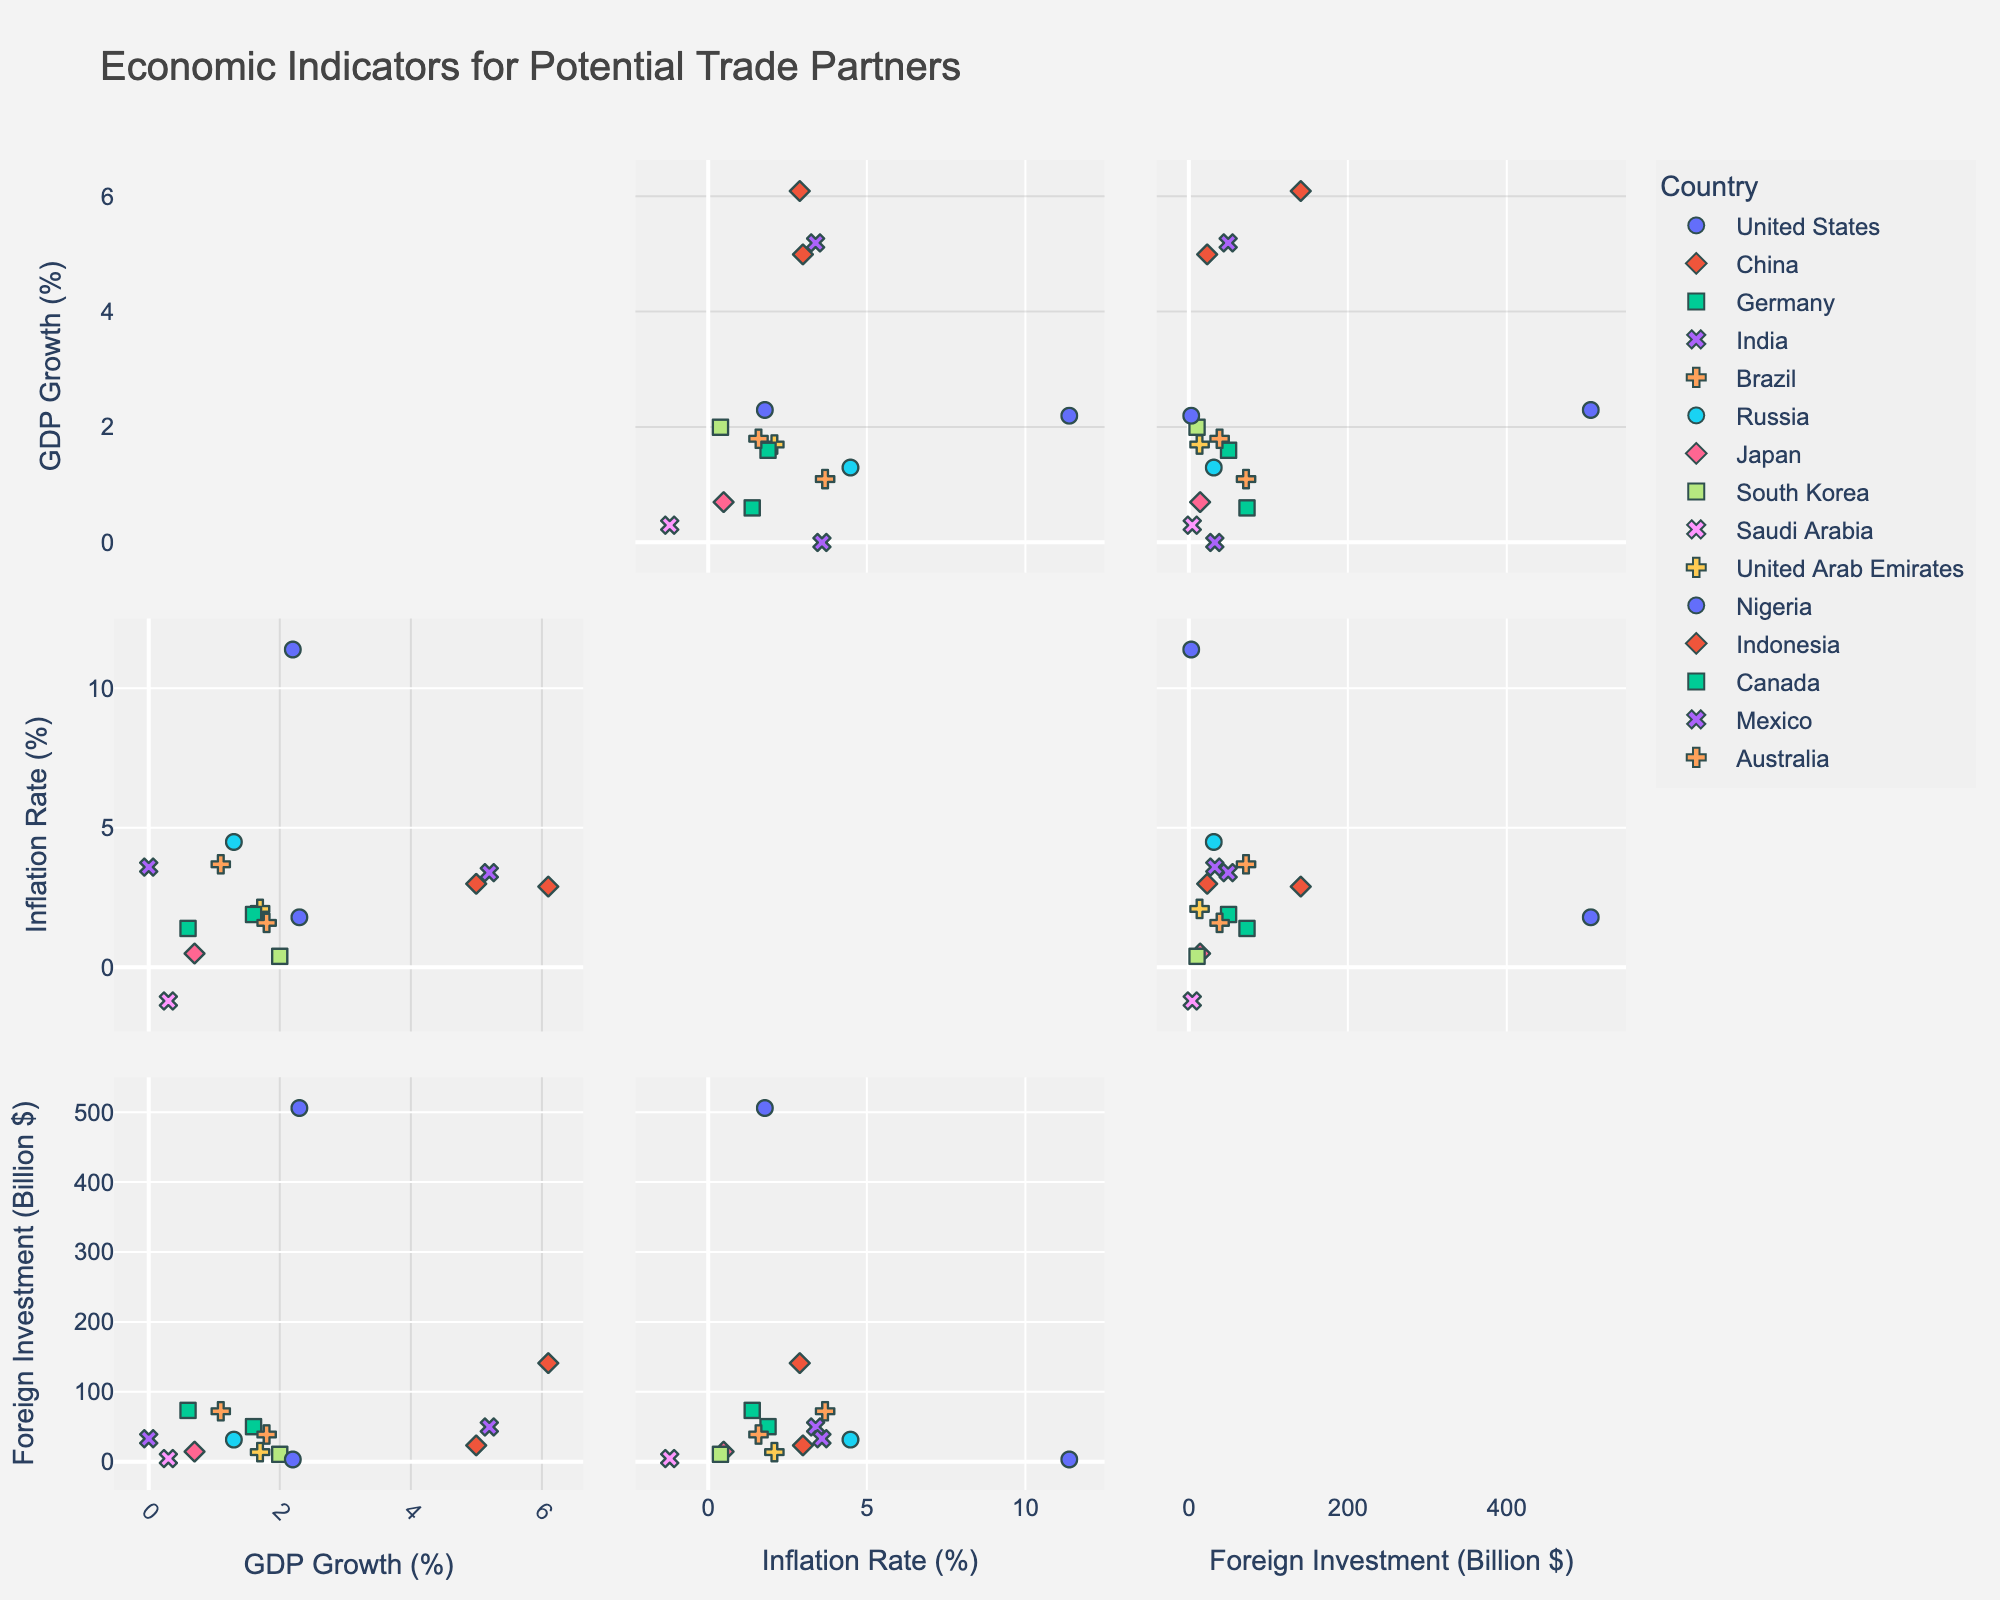What is the title of the figure? The title of the figure is displayed at the top and describes the content of the scatterplot matrix.
Answer: Economic Indicators for Potential Trade Partners How many data points represent countries with a negative inflation rate? Check the scatterplot where the Inflation Rate is plotted. Only Saudi Arabia has a negative inflation rate.
Answer: 1 Which country has the highest foreign investment? Locate the data point with the highest value on the Foreign Investment axis. The United States shows the highest foreign investment.
Answer: United States What is the GDP growth rate of Germany? Find the data point for Germany and look at its position on the GDP Growth axis.
Answer: 0.6% Between India and Brazil, which country has a higher inflation rate? Compare the positions of India and Brazil on the Inflation Rate axis. Brazil's data point is higher.
Answer: Brazil Which country has the lowest GDP growth rate? Identify the data point with the lowest value on the GDP Growth axis.
Answer: Mexico What is the combined foreign investment for Canada and Mexico? Look at the Foreign Investment values for Canada and Mexico, then add them together.
Answer: 83.3 billion $ How does the relationship between GDP growth and inflation rate compare between China and Nigeria? Locate the data points for China and Nigeria and assess their positions on both the GDP Growth and Inflation Rate axes. China's data point shows a higher GDP growth and lower inflation rate compared to Nigeria.
Answer: China has higher GDP growth and lower inflation Are there any countries with both GDP growth below 1% and foreign investment above 50 billion $? Cross-examine GDP Growth less than 1% and Foreign Investment greater than 50 billion $; Germany fits this criteria.
Answer: Germany 